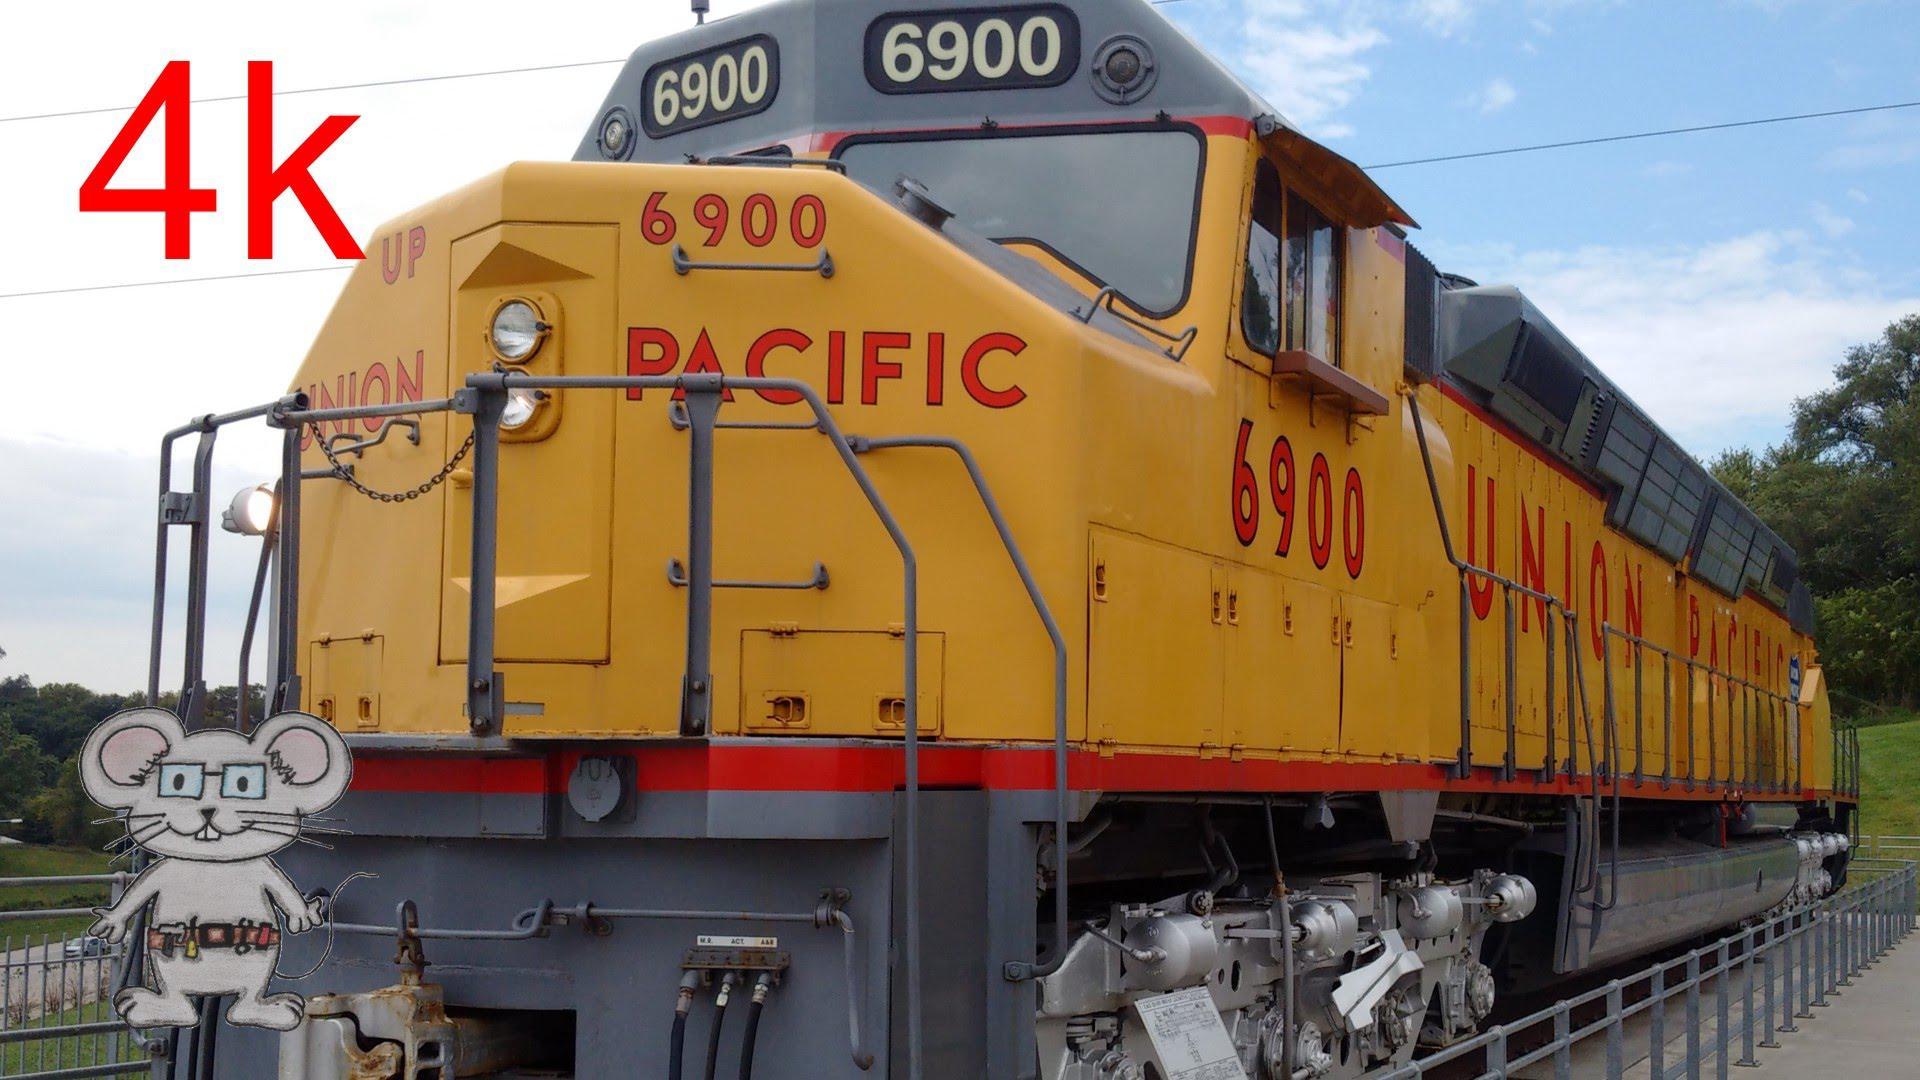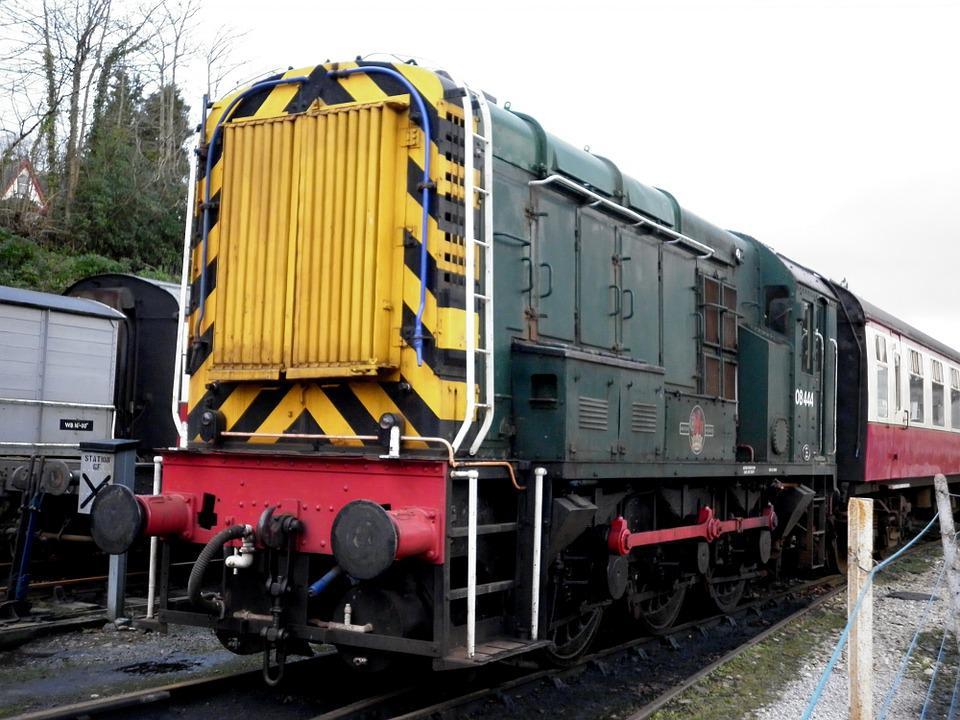The first image is the image on the left, the second image is the image on the right. Given the left and right images, does the statement "Thers is at least one ornage train." hold true? Answer yes or no. No. 